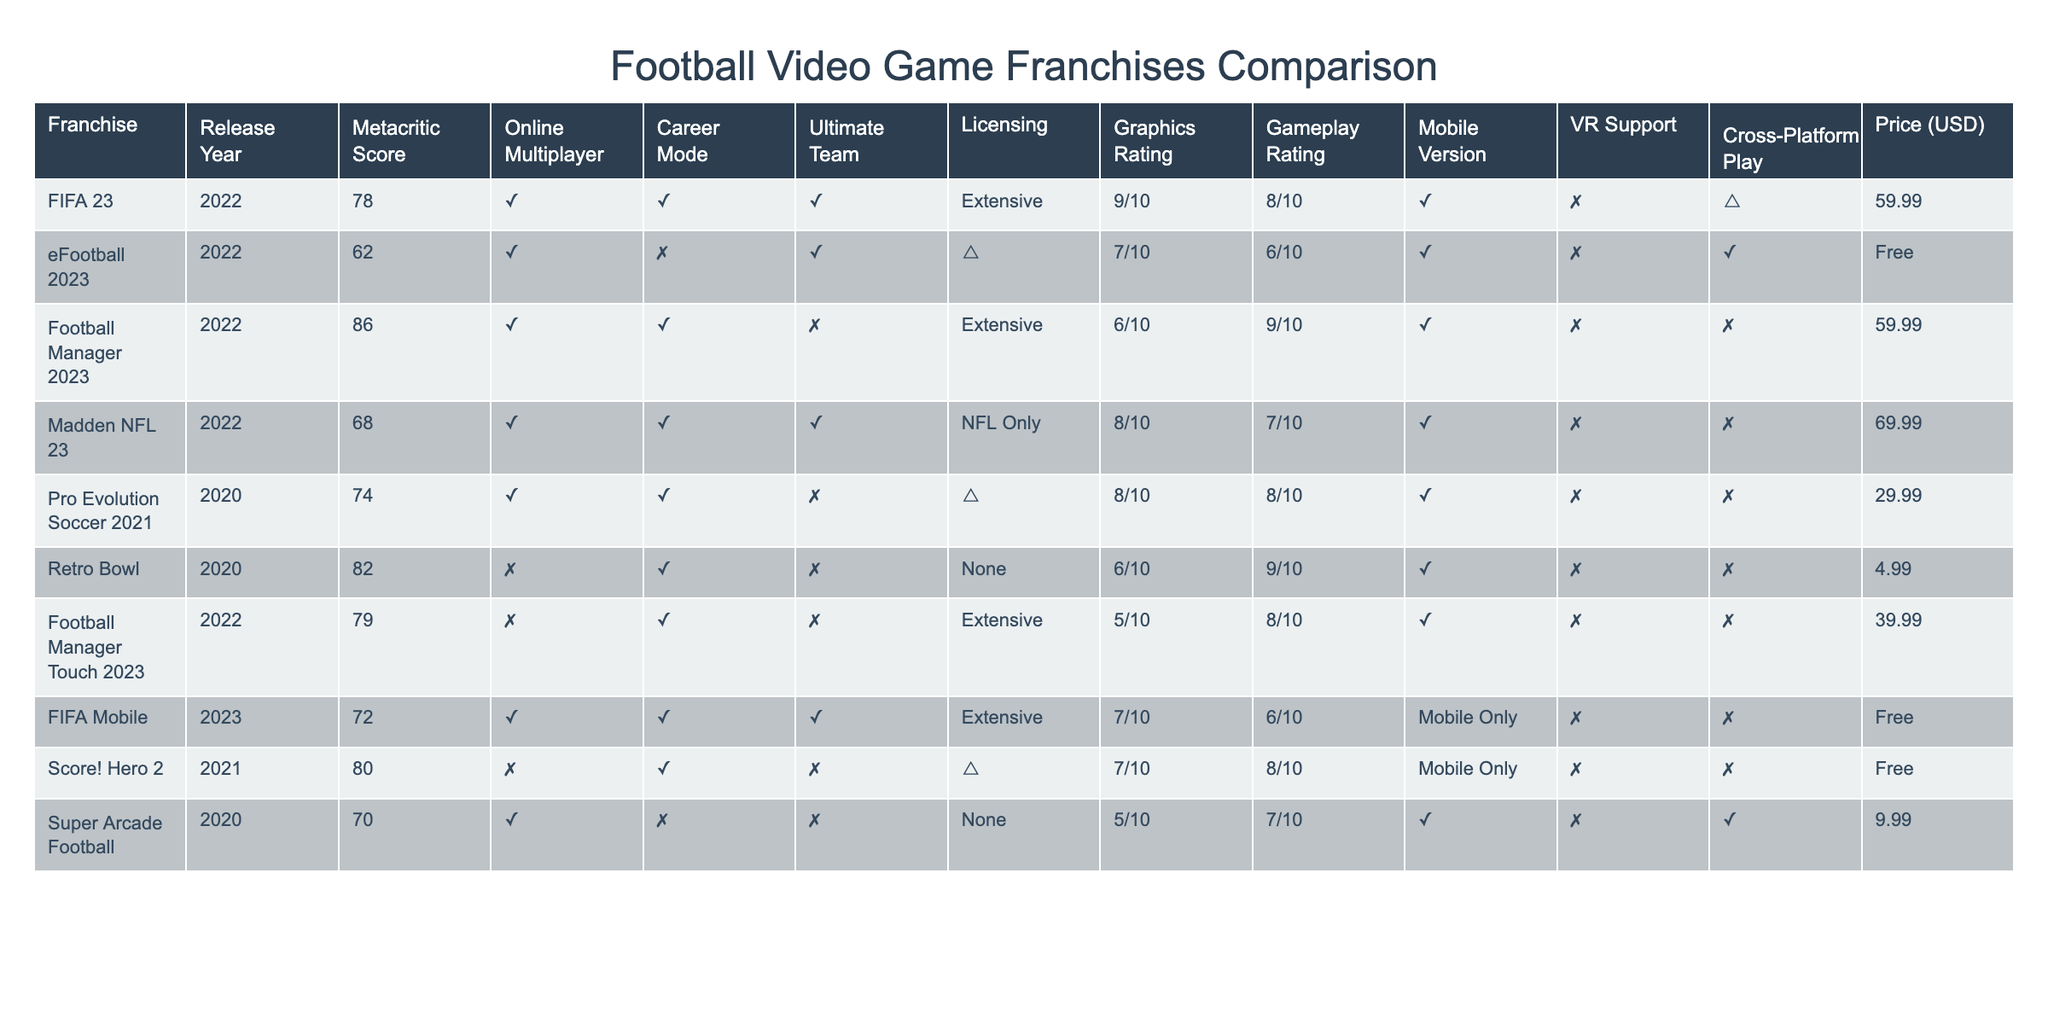What is the Metacritic score of FIFA 23? Looking at the table, the Metacritic score for FIFA 23 is clearly listed as 78.
Answer: 78 Which franchise offers cross-platform play? By examining the table, only eFootball 2023 has a "Yes" under the cross-platform play feature.
Answer: eFootball 2023 What is the price difference between Pro Evolution Soccer 2021 and FIFA Mobile? Pro Evolution Soccer 2021 is priced at 29.99, while FIFA Mobile is free. The difference is 29.99 - 0 = 29.99.
Answer: 29.99 What are the graphics ratings of eFootball 2023 and Football Manager 2023? eFootball 2023 has a graphics rating of 7/10 and Football Manager 2023 has 6/10, as indicated in the table.
Answer: eFootball 2023: 7/10, Football Manager 2023: 6/10 Which game has the highest Metacritic score, and what is the score? Scanning the Metacritic scores, Football Manager 2023 stands out with the highest score listed at 86.
Answer: Football Manager 2023, 86 Does Retro Bowl have online multiplayer? In the table, Retro Bowl is marked with "No" under online multiplayer, indicating it does not support this feature.
Answer: No How many games in this table support Ultimate Team? From the table, FIFA 23, eFootball 2023, and Madden NFL 23 have the Ultimate Team feature, totaling three games.
Answer: 3 Are the graphics ratings higher for eFootball 2023 than Retro Bowl? eFootball 2023 has a graphics rating of 7/10, while Retro Bowl scores a 6/10, so eFootball 2023 has a higher rating.
Answer: Yes Which game has the lowest price and what is it? The table shows Retro Bowl at a price of 4.99, making it the lowest priced game listed.
Answer: 4.99 Is there a game in the table that has no VR support but does have a mobile version? By examining the tables, we find that both FIFA Mobile and Score! Hero 2 have mobile versions and no VR support.
Answer: Yes, FIFA Mobile and Score! Hero 2 